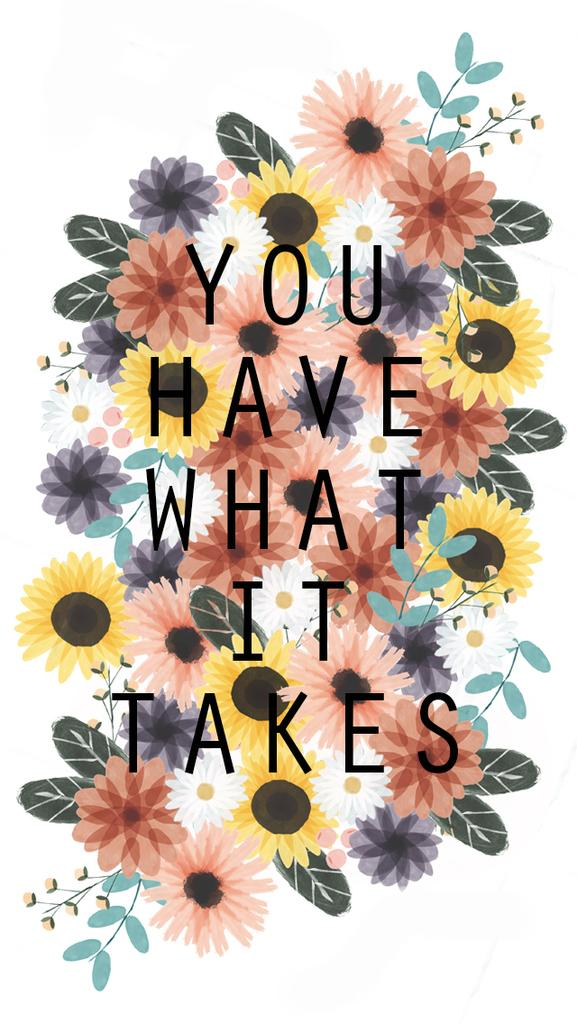What can be observed about the nature of the image? The image is edited. What type of natural elements can be seen in the image? There are flowers in the image. Are there any words or phrases present in the image? Yes, there is text in the image. What type of drain is visible in the image? There is no drain present in the image. What type of prose is written in the text of the image? There is no prose present in the image, as the text may contain various types of content, including but not limited to prose. 